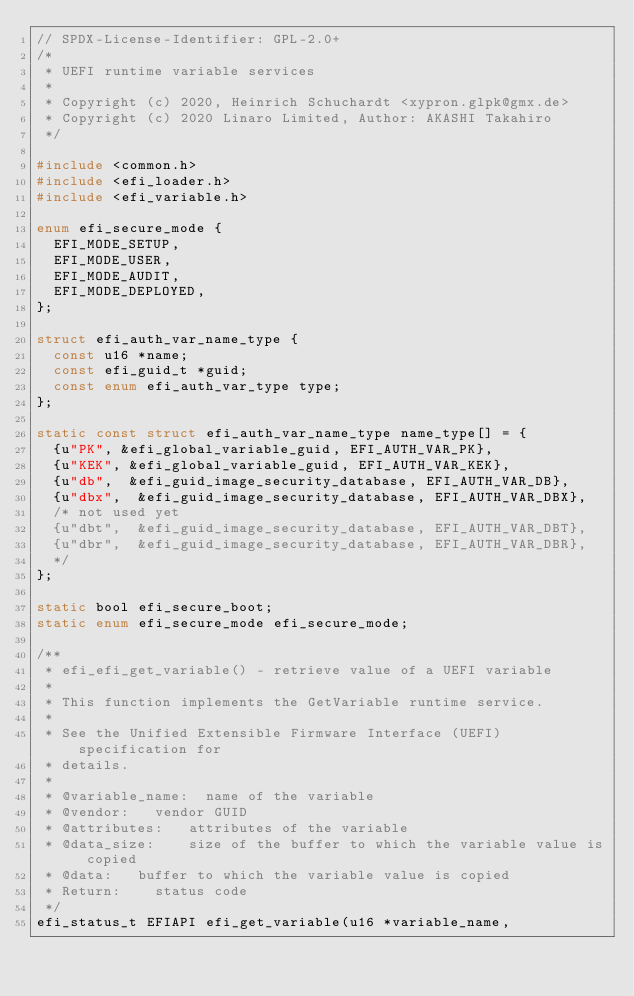Convert code to text. <code><loc_0><loc_0><loc_500><loc_500><_C_>// SPDX-License-Identifier: GPL-2.0+
/*
 * UEFI runtime variable services
 *
 * Copyright (c) 2020, Heinrich Schuchardt <xypron.glpk@gmx.de>
 * Copyright (c) 2020 Linaro Limited, Author: AKASHI Takahiro
 */

#include <common.h>
#include <efi_loader.h>
#include <efi_variable.h>

enum efi_secure_mode {
	EFI_MODE_SETUP,
	EFI_MODE_USER,
	EFI_MODE_AUDIT,
	EFI_MODE_DEPLOYED,
};

struct efi_auth_var_name_type {
	const u16 *name;
	const efi_guid_t *guid;
	const enum efi_auth_var_type type;
};

static const struct efi_auth_var_name_type name_type[] = {
	{u"PK", &efi_global_variable_guid, EFI_AUTH_VAR_PK},
	{u"KEK", &efi_global_variable_guid, EFI_AUTH_VAR_KEK},
	{u"db",  &efi_guid_image_security_database, EFI_AUTH_VAR_DB},
	{u"dbx",  &efi_guid_image_security_database, EFI_AUTH_VAR_DBX},
	/* not used yet
	{u"dbt",  &efi_guid_image_security_database, EFI_AUTH_VAR_DBT},
	{u"dbr",  &efi_guid_image_security_database, EFI_AUTH_VAR_DBR},
	*/
};

static bool efi_secure_boot;
static enum efi_secure_mode efi_secure_mode;

/**
 * efi_efi_get_variable() - retrieve value of a UEFI variable
 *
 * This function implements the GetVariable runtime service.
 *
 * See the Unified Extensible Firmware Interface (UEFI) specification for
 * details.
 *
 * @variable_name:	name of the variable
 * @vendor:		vendor GUID
 * @attributes:		attributes of the variable
 * @data_size:		size of the buffer to which the variable value is copied
 * @data:		buffer to which the variable value is copied
 * Return:		status code
 */
efi_status_t EFIAPI efi_get_variable(u16 *variable_name,</code> 